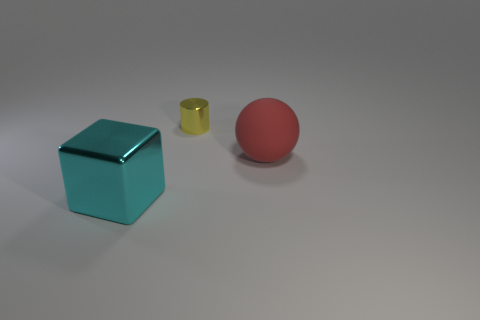Are there fewer tiny metal cylinders that are in front of the tiny thing than yellow cylinders that are in front of the red thing?
Ensure brevity in your answer.  No. Does the shiny object behind the big sphere have the same shape as the large shiny object?
Your answer should be compact. No. Are there any other things that have the same material as the big cyan block?
Offer a very short reply. Yes. Are the big thing behind the cube and the cyan block made of the same material?
Make the answer very short. No. What is the big object behind the metal object that is in front of the large thing that is on the right side of the large metallic thing made of?
Keep it short and to the point. Rubber. What number of other things are the same shape as the cyan metal thing?
Your response must be concise. 0. What color is the shiny object behind the big metal thing?
Ensure brevity in your answer.  Yellow. There is a shiny thing on the left side of the thing that is behind the large rubber thing; how many small yellow objects are on the right side of it?
Make the answer very short. 1. What number of large objects are behind the shiny thing to the left of the tiny shiny thing?
Your answer should be very brief. 1. How many tiny yellow cylinders are to the right of the ball?
Your answer should be compact. 0. 